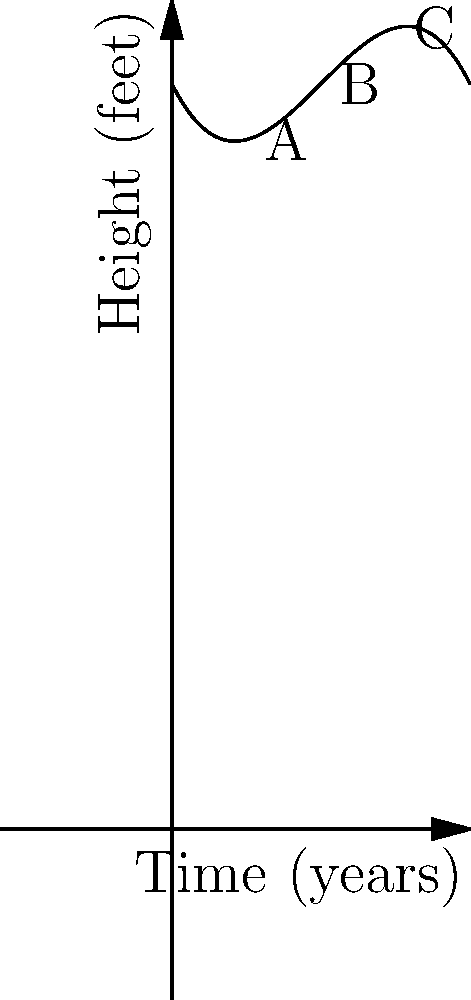The height of a traditional church steeple over time can be modeled by the polynomial function $h(t) = -0.01t^3 + 0.3t^2 - 2t + 50$, where $h$ is the height in feet and $t$ is the time in years since construction. At which point (A, B, or C) does the steeple reach its maximum height, and what might this represent in terms of the steeple's history? To determine the maximum height of the steeple, we need to follow these steps:

1) The maximum point of a polynomial function occurs where its first derivative equals zero. Let's find the derivative of $h(t)$:

   $h'(t) = -0.03t^2 + 0.6t - 2$

2) Set $h'(t) = 0$ and solve for $t$:

   $-0.03t^2 + 0.6t - 2 = 0$

3) This is a quadratic equation. We can solve it using the quadratic formula:

   $t = \frac{-b \pm \sqrt{b^2 - 4ac}}{2a}$

   Where $a = -0.03$, $b = 0.6$, and $c = -2$

4) Solving this gives us two solutions: $t \approx 10$ and $t \approx 20$

5) The solution $t \approx 10$ corresponds to the maximum point, as it falls within our graph's domain.

6) Looking at the graph, we can see that point B occurs at $t = 10$, which is where the steeple reaches its maximum height.

This maximum point likely represents the steeple at its best condition, perhaps after some initial settling and before significant deterioration begins. It symbolizes the peak of the steeple's structural integrity and aesthetic beauty, embodying the enduring nature of traditional architecture and craftsmanship.
Answer: Point B; represents the steeple's peak condition. 